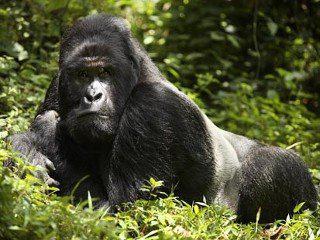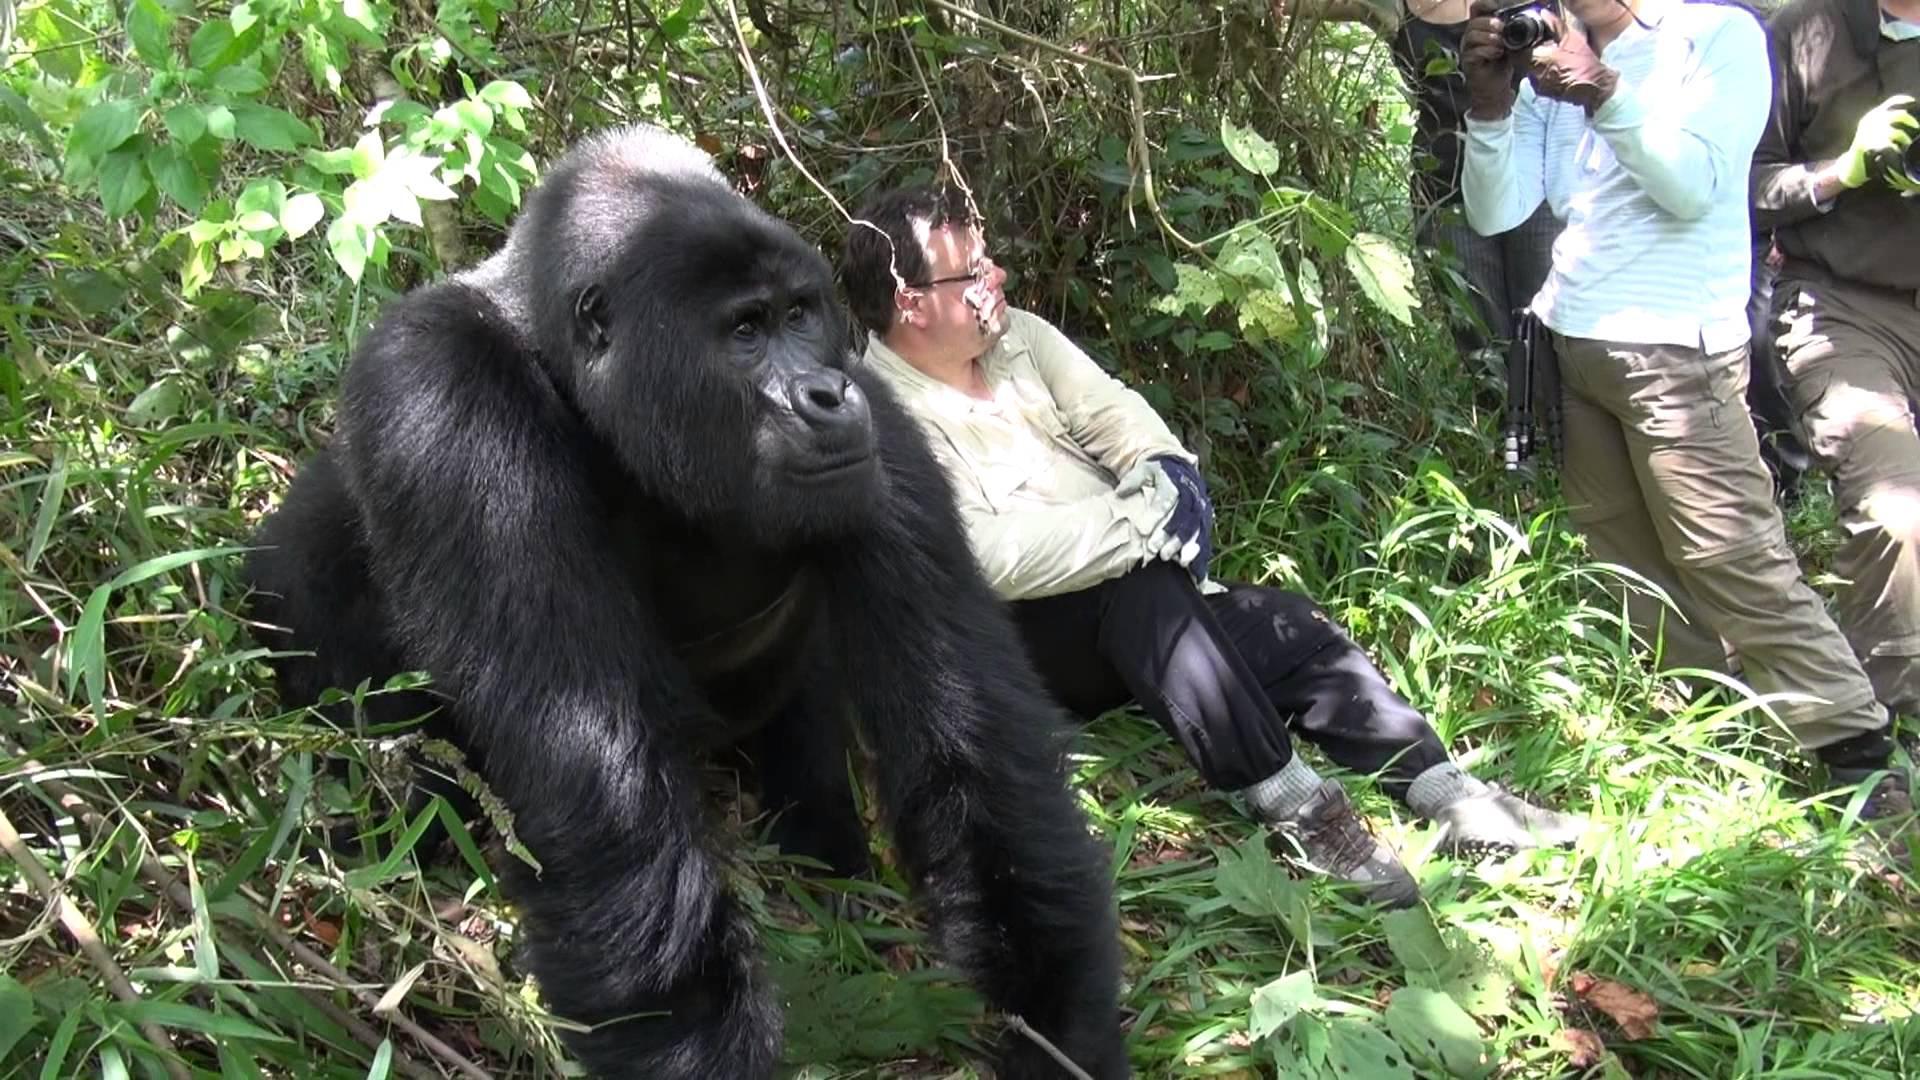The first image is the image on the left, the second image is the image on the right. Assess this claim about the two images: "There are humans taking pictures of apes in one of the images.". Correct or not? Answer yes or no. Yes. The first image is the image on the left, the second image is the image on the right. Analyze the images presented: Is the assertion "In the right image, multiple people are near an adult gorilla, and at least one person is holding up a camera." valid? Answer yes or no. Yes. 